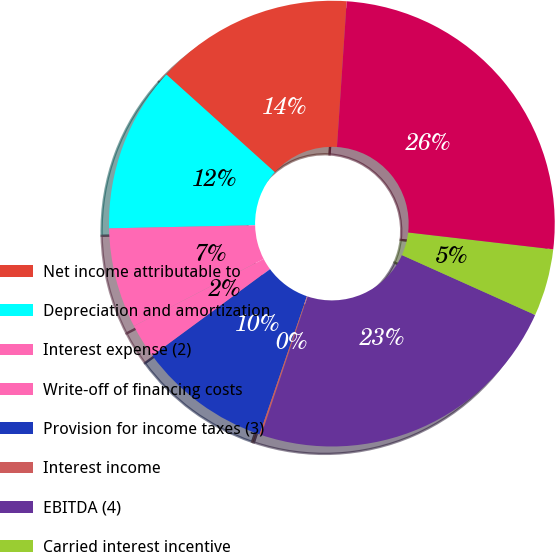Convert chart to OTSL. <chart><loc_0><loc_0><loc_500><loc_500><pie_chart><fcel>Net income attributable to<fcel>Depreciation and amortization<fcel>Interest expense (2)<fcel>Write-off of financing costs<fcel>Provision for income taxes (3)<fcel>Interest income<fcel>EBITDA (4)<fcel>Carried interest incentive<fcel>EBITDA as adjusted (4)<nl><fcel>14.39%<fcel>12.01%<fcel>7.26%<fcel>2.5%<fcel>9.64%<fcel>0.13%<fcel>23.41%<fcel>4.88%<fcel>25.78%<nl></chart> 